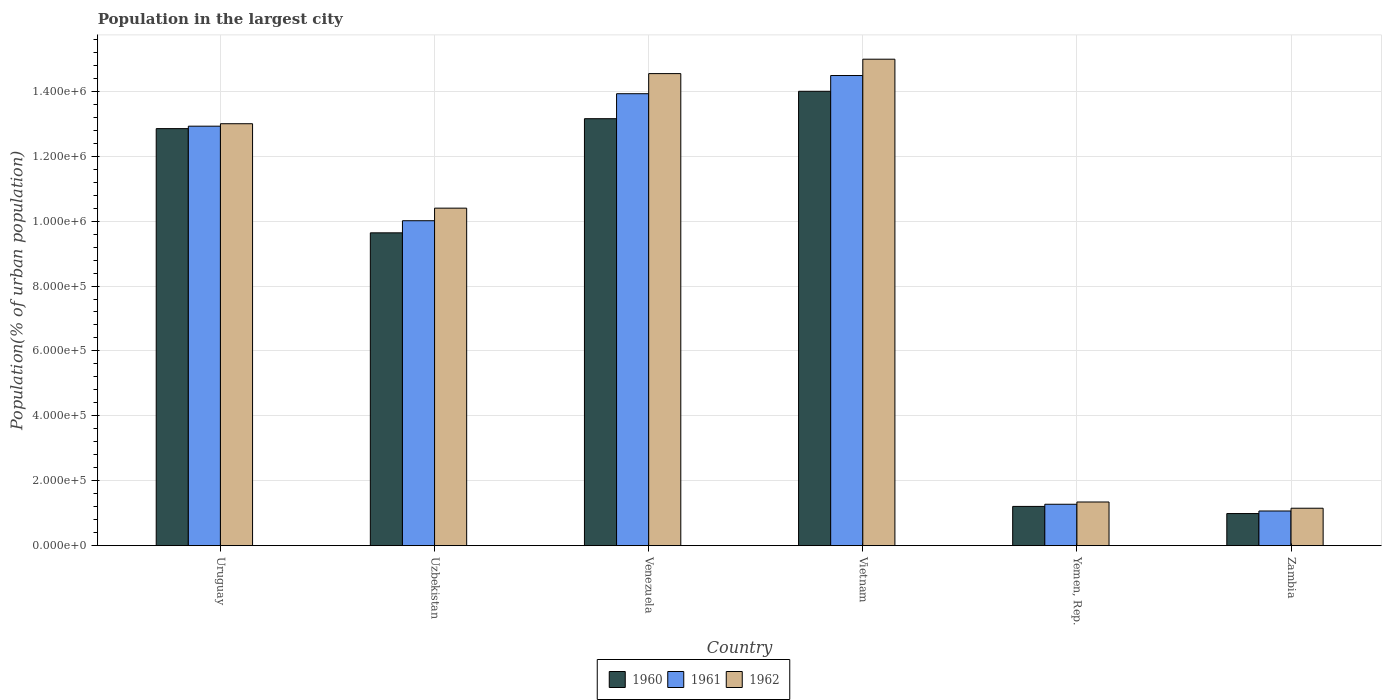How many different coloured bars are there?
Make the answer very short. 3. Are the number of bars per tick equal to the number of legend labels?
Ensure brevity in your answer.  Yes. Are the number of bars on each tick of the X-axis equal?
Provide a succinct answer. Yes. What is the label of the 3rd group of bars from the left?
Give a very brief answer. Venezuela. In how many cases, is the number of bars for a given country not equal to the number of legend labels?
Your answer should be very brief. 0. What is the population in the largest city in 1960 in Yemen, Rep.?
Offer a terse response. 1.21e+05. Across all countries, what is the maximum population in the largest city in 1962?
Ensure brevity in your answer.  1.50e+06. Across all countries, what is the minimum population in the largest city in 1961?
Offer a very short reply. 1.07e+05. In which country was the population in the largest city in 1961 maximum?
Make the answer very short. Vietnam. In which country was the population in the largest city in 1960 minimum?
Your answer should be compact. Zambia. What is the total population in the largest city in 1962 in the graph?
Offer a very short reply. 5.54e+06. What is the difference between the population in the largest city in 1960 in Uzbekistan and that in Yemen, Rep.?
Your answer should be very brief. 8.43e+05. What is the difference between the population in the largest city in 1962 in Uzbekistan and the population in the largest city in 1960 in Venezuela?
Your response must be concise. -2.76e+05. What is the average population in the largest city in 1962 per country?
Keep it short and to the point. 9.24e+05. What is the difference between the population in the largest city of/in 1960 and population in the largest city of/in 1961 in Yemen, Rep.?
Ensure brevity in your answer.  -6622. What is the ratio of the population in the largest city in 1960 in Venezuela to that in Vietnam?
Keep it short and to the point. 0.94. Is the population in the largest city in 1961 in Uruguay less than that in Yemen, Rep.?
Make the answer very short. No. Is the difference between the population in the largest city in 1960 in Venezuela and Zambia greater than the difference between the population in the largest city in 1961 in Venezuela and Zambia?
Provide a short and direct response. No. What is the difference between the highest and the second highest population in the largest city in 1961?
Provide a succinct answer. 1.00e+05. What is the difference between the highest and the lowest population in the largest city in 1960?
Your response must be concise. 1.30e+06. Is it the case that in every country, the sum of the population in the largest city in 1960 and population in the largest city in 1961 is greater than the population in the largest city in 1962?
Your answer should be compact. Yes. How many bars are there?
Keep it short and to the point. 18. How many countries are there in the graph?
Provide a short and direct response. 6. Are the values on the major ticks of Y-axis written in scientific E-notation?
Keep it short and to the point. Yes. Where does the legend appear in the graph?
Ensure brevity in your answer.  Bottom center. How many legend labels are there?
Ensure brevity in your answer.  3. How are the legend labels stacked?
Ensure brevity in your answer.  Horizontal. What is the title of the graph?
Give a very brief answer. Population in the largest city. Does "2011" appear as one of the legend labels in the graph?
Your answer should be very brief. No. What is the label or title of the X-axis?
Your response must be concise. Country. What is the label or title of the Y-axis?
Your response must be concise. Population(% of urban population). What is the Population(% of urban population) in 1960 in Uruguay?
Provide a succinct answer. 1.28e+06. What is the Population(% of urban population) in 1961 in Uruguay?
Your answer should be very brief. 1.29e+06. What is the Population(% of urban population) of 1962 in Uruguay?
Your response must be concise. 1.30e+06. What is the Population(% of urban population) of 1960 in Uzbekistan?
Provide a succinct answer. 9.64e+05. What is the Population(% of urban population) in 1961 in Uzbekistan?
Keep it short and to the point. 1.00e+06. What is the Population(% of urban population) in 1962 in Uzbekistan?
Provide a short and direct response. 1.04e+06. What is the Population(% of urban population) in 1960 in Venezuela?
Provide a succinct answer. 1.32e+06. What is the Population(% of urban population) in 1961 in Venezuela?
Ensure brevity in your answer.  1.39e+06. What is the Population(% of urban population) of 1962 in Venezuela?
Your answer should be very brief. 1.45e+06. What is the Population(% of urban population) of 1960 in Vietnam?
Ensure brevity in your answer.  1.40e+06. What is the Population(% of urban population) of 1961 in Vietnam?
Make the answer very short. 1.45e+06. What is the Population(% of urban population) of 1962 in Vietnam?
Your response must be concise. 1.50e+06. What is the Population(% of urban population) in 1960 in Yemen, Rep.?
Keep it short and to the point. 1.21e+05. What is the Population(% of urban population) in 1961 in Yemen, Rep.?
Give a very brief answer. 1.28e+05. What is the Population(% of urban population) of 1962 in Yemen, Rep.?
Provide a succinct answer. 1.35e+05. What is the Population(% of urban population) of 1960 in Zambia?
Your response must be concise. 9.90e+04. What is the Population(% of urban population) of 1961 in Zambia?
Ensure brevity in your answer.  1.07e+05. What is the Population(% of urban population) in 1962 in Zambia?
Offer a terse response. 1.15e+05. Across all countries, what is the maximum Population(% of urban population) of 1960?
Keep it short and to the point. 1.40e+06. Across all countries, what is the maximum Population(% of urban population) in 1961?
Offer a terse response. 1.45e+06. Across all countries, what is the maximum Population(% of urban population) in 1962?
Provide a succinct answer. 1.50e+06. Across all countries, what is the minimum Population(% of urban population) in 1960?
Provide a short and direct response. 9.90e+04. Across all countries, what is the minimum Population(% of urban population) of 1961?
Your answer should be very brief. 1.07e+05. Across all countries, what is the minimum Population(% of urban population) in 1962?
Your answer should be compact. 1.15e+05. What is the total Population(% of urban population) of 1960 in the graph?
Ensure brevity in your answer.  5.18e+06. What is the total Population(% of urban population) of 1961 in the graph?
Make the answer very short. 5.37e+06. What is the total Population(% of urban population) of 1962 in the graph?
Your answer should be very brief. 5.54e+06. What is the difference between the Population(% of urban population) of 1960 in Uruguay and that in Uzbekistan?
Give a very brief answer. 3.21e+05. What is the difference between the Population(% of urban population) in 1961 in Uruguay and that in Uzbekistan?
Your response must be concise. 2.91e+05. What is the difference between the Population(% of urban population) in 1962 in Uruguay and that in Uzbekistan?
Ensure brevity in your answer.  2.60e+05. What is the difference between the Population(% of urban population) in 1960 in Uruguay and that in Venezuela?
Your response must be concise. -3.06e+04. What is the difference between the Population(% of urban population) of 1961 in Uruguay and that in Venezuela?
Make the answer very short. -1.00e+05. What is the difference between the Population(% of urban population) of 1962 in Uruguay and that in Venezuela?
Ensure brevity in your answer.  -1.54e+05. What is the difference between the Population(% of urban population) in 1960 in Uruguay and that in Vietnam?
Give a very brief answer. -1.15e+05. What is the difference between the Population(% of urban population) of 1961 in Uruguay and that in Vietnam?
Provide a succinct answer. -1.56e+05. What is the difference between the Population(% of urban population) of 1962 in Uruguay and that in Vietnam?
Your response must be concise. -1.99e+05. What is the difference between the Population(% of urban population) of 1960 in Uruguay and that in Yemen, Rep.?
Your response must be concise. 1.16e+06. What is the difference between the Population(% of urban population) in 1961 in Uruguay and that in Yemen, Rep.?
Provide a short and direct response. 1.16e+06. What is the difference between the Population(% of urban population) in 1962 in Uruguay and that in Yemen, Rep.?
Give a very brief answer. 1.17e+06. What is the difference between the Population(% of urban population) of 1960 in Uruguay and that in Zambia?
Provide a succinct answer. 1.19e+06. What is the difference between the Population(% of urban population) in 1961 in Uruguay and that in Zambia?
Your response must be concise. 1.19e+06. What is the difference between the Population(% of urban population) of 1962 in Uruguay and that in Zambia?
Provide a short and direct response. 1.18e+06. What is the difference between the Population(% of urban population) in 1960 in Uzbekistan and that in Venezuela?
Your response must be concise. -3.52e+05. What is the difference between the Population(% of urban population) of 1961 in Uzbekistan and that in Venezuela?
Your answer should be compact. -3.91e+05. What is the difference between the Population(% of urban population) of 1962 in Uzbekistan and that in Venezuela?
Provide a short and direct response. -4.15e+05. What is the difference between the Population(% of urban population) in 1960 in Uzbekistan and that in Vietnam?
Your answer should be compact. -4.36e+05. What is the difference between the Population(% of urban population) of 1961 in Uzbekistan and that in Vietnam?
Offer a terse response. -4.47e+05. What is the difference between the Population(% of urban population) of 1962 in Uzbekistan and that in Vietnam?
Your response must be concise. -4.59e+05. What is the difference between the Population(% of urban population) in 1960 in Uzbekistan and that in Yemen, Rep.?
Keep it short and to the point. 8.43e+05. What is the difference between the Population(% of urban population) of 1961 in Uzbekistan and that in Yemen, Rep.?
Keep it short and to the point. 8.74e+05. What is the difference between the Population(% of urban population) of 1962 in Uzbekistan and that in Yemen, Rep.?
Your response must be concise. 9.05e+05. What is the difference between the Population(% of urban population) in 1960 in Uzbekistan and that in Zambia?
Offer a terse response. 8.65e+05. What is the difference between the Population(% of urban population) in 1961 in Uzbekistan and that in Zambia?
Ensure brevity in your answer.  8.94e+05. What is the difference between the Population(% of urban population) in 1962 in Uzbekistan and that in Zambia?
Keep it short and to the point. 9.25e+05. What is the difference between the Population(% of urban population) in 1960 in Venezuela and that in Vietnam?
Make the answer very short. -8.45e+04. What is the difference between the Population(% of urban population) of 1961 in Venezuela and that in Vietnam?
Keep it short and to the point. -5.60e+04. What is the difference between the Population(% of urban population) of 1962 in Venezuela and that in Vietnam?
Ensure brevity in your answer.  -4.44e+04. What is the difference between the Population(% of urban population) of 1960 in Venezuela and that in Yemen, Rep.?
Offer a terse response. 1.19e+06. What is the difference between the Population(% of urban population) of 1961 in Venezuela and that in Yemen, Rep.?
Offer a very short reply. 1.26e+06. What is the difference between the Population(% of urban population) in 1962 in Venezuela and that in Yemen, Rep.?
Offer a terse response. 1.32e+06. What is the difference between the Population(% of urban population) of 1960 in Venezuela and that in Zambia?
Provide a short and direct response. 1.22e+06. What is the difference between the Population(% of urban population) of 1961 in Venezuela and that in Zambia?
Your answer should be compact. 1.29e+06. What is the difference between the Population(% of urban population) in 1962 in Venezuela and that in Zambia?
Provide a succinct answer. 1.34e+06. What is the difference between the Population(% of urban population) of 1960 in Vietnam and that in Yemen, Rep.?
Your answer should be very brief. 1.28e+06. What is the difference between the Population(% of urban population) of 1961 in Vietnam and that in Yemen, Rep.?
Offer a terse response. 1.32e+06. What is the difference between the Population(% of urban population) in 1962 in Vietnam and that in Yemen, Rep.?
Keep it short and to the point. 1.36e+06. What is the difference between the Population(% of urban population) of 1960 in Vietnam and that in Zambia?
Your response must be concise. 1.30e+06. What is the difference between the Population(% of urban population) in 1961 in Vietnam and that in Zambia?
Make the answer very short. 1.34e+06. What is the difference between the Population(% of urban population) of 1962 in Vietnam and that in Zambia?
Keep it short and to the point. 1.38e+06. What is the difference between the Population(% of urban population) of 1960 in Yemen, Rep. and that in Zambia?
Make the answer very short. 2.20e+04. What is the difference between the Population(% of urban population) of 1961 in Yemen, Rep. and that in Zambia?
Make the answer very short. 2.08e+04. What is the difference between the Population(% of urban population) of 1962 in Yemen, Rep. and that in Zambia?
Your response must be concise. 1.92e+04. What is the difference between the Population(% of urban population) of 1960 in Uruguay and the Population(% of urban population) of 1961 in Uzbekistan?
Provide a succinct answer. 2.84e+05. What is the difference between the Population(% of urban population) in 1960 in Uruguay and the Population(% of urban population) in 1962 in Uzbekistan?
Ensure brevity in your answer.  2.45e+05. What is the difference between the Population(% of urban population) in 1961 in Uruguay and the Population(% of urban population) in 1962 in Uzbekistan?
Your response must be concise. 2.53e+05. What is the difference between the Population(% of urban population) of 1960 in Uruguay and the Population(% of urban population) of 1961 in Venezuela?
Offer a terse response. -1.08e+05. What is the difference between the Population(% of urban population) of 1960 in Uruguay and the Population(% of urban population) of 1962 in Venezuela?
Your answer should be very brief. -1.70e+05. What is the difference between the Population(% of urban population) of 1961 in Uruguay and the Population(% of urban population) of 1962 in Venezuela?
Ensure brevity in your answer.  -1.62e+05. What is the difference between the Population(% of urban population) in 1960 in Uruguay and the Population(% of urban population) in 1961 in Vietnam?
Make the answer very short. -1.64e+05. What is the difference between the Population(% of urban population) of 1960 in Uruguay and the Population(% of urban population) of 1962 in Vietnam?
Offer a very short reply. -2.14e+05. What is the difference between the Population(% of urban population) in 1961 in Uruguay and the Population(% of urban population) in 1962 in Vietnam?
Your response must be concise. -2.06e+05. What is the difference between the Population(% of urban population) of 1960 in Uruguay and the Population(% of urban population) of 1961 in Yemen, Rep.?
Make the answer very short. 1.16e+06. What is the difference between the Population(% of urban population) in 1960 in Uruguay and the Population(% of urban population) in 1962 in Yemen, Rep.?
Offer a terse response. 1.15e+06. What is the difference between the Population(% of urban population) of 1961 in Uruguay and the Population(% of urban population) of 1962 in Yemen, Rep.?
Offer a terse response. 1.16e+06. What is the difference between the Population(% of urban population) of 1960 in Uruguay and the Population(% of urban population) of 1961 in Zambia?
Offer a terse response. 1.18e+06. What is the difference between the Population(% of urban population) in 1960 in Uruguay and the Population(% of urban population) in 1962 in Zambia?
Offer a very short reply. 1.17e+06. What is the difference between the Population(% of urban population) in 1961 in Uruguay and the Population(% of urban population) in 1962 in Zambia?
Provide a succinct answer. 1.18e+06. What is the difference between the Population(% of urban population) of 1960 in Uzbekistan and the Population(% of urban population) of 1961 in Venezuela?
Keep it short and to the point. -4.29e+05. What is the difference between the Population(% of urban population) of 1960 in Uzbekistan and the Population(% of urban population) of 1962 in Venezuela?
Your answer should be compact. -4.91e+05. What is the difference between the Population(% of urban population) of 1961 in Uzbekistan and the Population(% of urban population) of 1962 in Venezuela?
Provide a succinct answer. -4.53e+05. What is the difference between the Population(% of urban population) of 1960 in Uzbekistan and the Population(% of urban population) of 1961 in Vietnam?
Your answer should be very brief. -4.85e+05. What is the difference between the Population(% of urban population) of 1960 in Uzbekistan and the Population(% of urban population) of 1962 in Vietnam?
Offer a very short reply. -5.35e+05. What is the difference between the Population(% of urban population) in 1961 in Uzbekistan and the Population(% of urban population) in 1962 in Vietnam?
Ensure brevity in your answer.  -4.98e+05. What is the difference between the Population(% of urban population) in 1960 in Uzbekistan and the Population(% of urban population) in 1961 in Yemen, Rep.?
Ensure brevity in your answer.  8.36e+05. What is the difference between the Population(% of urban population) of 1960 in Uzbekistan and the Population(% of urban population) of 1962 in Yemen, Rep.?
Provide a short and direct response. 8.29e+05. What is the difference between the Population(% of urban population) of 1961 in Uzbekistan and the Population(% of urban population) of 1962 in Yemen, Rep.?
Offer a very short reply. 8.67e+05. What is the difference between the Population(% of urban population) in 1960 in Uzbekistan and the Population(% of urban population) in 1961 in Zambia?
Offer a terse response. 8.57e+05. What is the difference between the Population(% of urban population) of 1960 in Uzbekistan and the Population(% of urban population) of 1962 in Zambia?
Give a very brief answer. 8.49e+05. What is the difference between the Population(% of urban population) in 1961 in Uzbekistan and the Population(% of urban population) in 1962 in Zambia?
Provide a succinct answer. 8.86e+05. What is the difference between the Population(% of urban population) in 1960 in Venezuela and the Population(% of urban population) in 1961 in Vietnam?
Offer a terse response. -1.33e+05. What is the difference between the Population(% of urban population) in 1960 in Venezuela and the Population(% of urban population) in 1962 in Vietnam?
Keep it short and to the point. -1.83e+05. What is the difference between the Population(% of urban population) of 1961 in Venezuela and the Population(% of urban population) of 1962 in Vietnam?
Give a very brief answer. -1.06e+05. What is the difference between the Population(% of urban population) in 1960 in Venezuela and the Population(% of urban population) in 1961 in Yemen, Rep.?
Your answer should be compact. 1.19e+06. What is the difference between the Population(% of urban population) of 1960 in Venezuela and the Population(% of urban population) of 1962 in Yemen, Rep.?
Offer a terse response. 1.18e+06. What is the difference between the Population(% of urban population) in 1961 in Venezuela and the Population(% of urban population) in 1962 in Yemen, Rep.?
Your answer should be very brief. 1.26e+06. What is the difference between the Population(% of urban population) of 1960 in Venezuela and the Population(% of urban population) of 1961 in Zambia?
Make the answer very short. 1.21e+06. What is the difference between the Population(% of urban population) in 1960 in Venezuela and the Population(% of urban population) in 1962 in Zambia?
Make the answer very short. 1.20e+06. What is the difference between the Population(% of urban population) of 1961 in Venezuela and the Population(% of urban population) of 1962 in Zambia?
Your response must be concise. 1.28e+06. What is the difference between the Population(% of urban population) of 1960 in Vietnam and the Population(% of urban population) of 1961 in Yemen, Rep.?
Give a very brief answer. 1.27e+06. What is the difference between the Population(% of urban population) in 1960 in Vietnam and the Population(% of urban population) in 1962 in Yemen, Rep.?
Provide a short and direct response. 1.27e+06. What is the difference between the Population(% of urban population) of 1961 in Vietnam and the Population(% of urban population) of 1962 in Yemen, Rep.?
Provide a succinct answer. 1.31e+06. What is the difference between the Population(% of urban population) in 1960 in Vietnam and the Population(% of urban population) in 1961 in Zambia?
Ensure brevity in your answer.  1.29e+06. What is the difference between the Population(% of urban population) in 1960 in Vietnam and the Population(% of urban population) in 1962 in Zambia?
Offer a very short reply. 1.28e+06. What is the difference between the Population(% of urban population) in 1961 in Vietnam and the Population(% of urban population) in 1962 in Zambia?
Offer a very short reply. 1.33e+06. What is the difference between the Population(% of urban population) of 1960 in Yemen, Rep. and the Population(% of urban population) of 1961 in Zambia?
Offer a terse response. 1.41e+04. What is the difference between the Population(% of urban population) in 1960 in Yemen, Rep. and the Population(% of urban population) in 1962 in Zambia?
Provide a short and direct response. 5601. What is the difference between the Population(% of urban population) in 1961 in Yemen, Rep. and the Population(% of urban population) in 1962 in Zambia?
Provide a short and direct response. 1.22e+04. What is the average Population(% of urban population) in 1960 per country?
Your answer should be compact. 8.64e+05. What is the average Population(% of urban population) of 1961 per country?
Offer a terse response. 8.95e+05. What is the average Population(% of urban population) in 1962 per country?
Offer a very short reply. 9.24e+05. What is the difference between the Population(% of urban population) in 1960 and Population(% of urban population) in 1961 in Uruguay?
Ensure brevity in your answer.  -7522. What is the difference between the Population(% of urban population) in 1960 and Population(% of urban population) in 1962 in Uruguay?
Your answer should be very brief. -1.51e+04. What is the difference between the Population(% of urban population) in 1961 and Population(% of urban population) in 1962 in Uruguay?
Your response must be concise. -7578. What is the difference between the Population(% of urban population) in 1960 and Population(% of urban population) in 1961 in Uzbekistan?
Your answer should be very brief. -3.73e+04. What is the difference between the Population(% of urban population) of 1960 and Population(% of urban population) of 1962 in Uzbekistan?
Give a very brief answer. -7.60e+04. What is the difference between the Population(% of urban population) in 1961 and Population(% of urban population) in 1962 in Uzbekistan?
Ensure brevity in your answer.  -3.88e+04. What is the difference between the Population(% of urban population) in 1960 and Population(% of urban population) in 1961 in Venezuela?
Provide a short and direct response. -7.70e+04. What is the difference between the Population(% of urban population) of 1960 and Population(% of urban population) of 1962 in Venezuela?
Ensure brevity in your answer.  -1.39e+05. What is the difference between the Population(% of urban population) of 1961 and Population(% of urban population) of 1962 in Venezuela?
Offer a very short reply. -6.19e+04. What is the difference between the Population(% of urban population) in 1960 and Population(% of urban population) in 1961 in Vietnam?
Provide a short and direct response. -4.86e+04. What is the difference between the Population(% of urban population) of 1960 and Population(% of urban population) of 1962 in Vietnam?
Offer a very short reply. -9.89e+04. What is the difference between the Population(% of urban population) in 1961 and Population(% of urban population) in 1962 in Vietnam?
Provide a succinct answer. -5.03e+04. What is the difference between the Population(% of urban population) of 1960 and Population(% of urban population) of 1961 in Yemen, Rep.?
Provide a short and direct response. -6622. What is the difference between the Population(% of urban population) of 1960 and Population(% of urban population) of 1962 in Yemen, Rep.?
Offer a terse response. -1.36e+04. What is the difference between the Population(% of urban population) of 1961 and Population(% of urban population) of 1962 in Yemen, Rep.?
Your answer should be very brief. -6994. What is the difference between the Population(% of urban population) of 1960 and Population(% of urban population) of 1961 in Zambia?
Offer a very short reply. -7895. What is the difference between the Population(% of urban population) of 1960 and Population(% of urban population) of 1962 in Zambia?
Provide a succinct answer. -1.64e+04. What is the difference between the Population(% of urban population) of 1961 and Population(% of urban population) of 1962 in Zambia?
Ensure brevity in your answer.  -8536. What is the ratio of the Population(% of urban population) in 1960 in Uruguay to that in Uzbekistan?
Your response must be concise. 1.33. What is the ratio of the Population(% of urban population) of 1961 in Uruguay to that in Uzbekistan?
Offer a very short reply. 1.29. What is the ratio of the Population(% of urban population) of 1962 in Uruguay to that in Uzbekistan?
Give a very brief answer. 1.25. What is the ratio of the Population(% of urban population) of 1960 in Uruguay to that in Venezuela?
Offer a terse response. 0.98. What is the ratio of the Population(% of urban population) in 1961 in Uruguay to that in Venezuela?
Give a very brief answer. 0.93. What is the ratio of the Population(% of urban population) of 1962 in Uruguay to that in Venezuela?
Give a very brief answer. 0.89. What is the ratio of the Population(% of urban population) in 1960 in Uruguay to that in Vietnam?
Provide a short and direct response. 0.92. What is the ratio of the Population(% of urban population) in 1961 in Uruguay to that in Vietnam?
Provide a succinct answer. 0.89. What is the ratio of the Population(% of urban population) in 1962 in Uruguay to that in Vietnam?
Keep it short and to the point. 0.87. What is the ratio of the Population(% of urban population) in 1960 in Uruguay to that in Yemen, Rep.?
Offer a very short reply. 10.62. What is the ratio of the Population(% of urban population) of 1961 in Uruguay to that in Yemen, Rep.?
Provide a succinct answer. 10.13. What is the ratio of the Population(% of urban population) of 1962 in Uruguay to that in Yemen, Rep.?
Your answer should be very brief. 9.66. What is the ratio of the Population(% of urban population) in 1960 in Uruguay to that in Zambia?
Your answer should be compact. 12.98. What is the ratio of the Population(% of urban population) of 1961 in Uruguay to that in Zambia?
Give a very brief answer. 12.09. What is the ratio of the Population(% of urban population) of 1962 in Uruguay to that in Zambia?
Keep it short and to the point. 11.27. What is the ratio of the Population(% of urban population) of 1960 in Uzbekistan to that in Venezuela?
Your answer should be compact. 0.73. What is the ratio of the Population(% of urban population) of 1961 in Uzbekistan to that in Venezuela?
Offer a terse response. 0.72. What is the ratio of the Population(% of urban population) in 1962 in Uzbekistan to that in Venezuela?
Provide a succinct answer. 0.71. What is the ratio of the Population(% of urban population) in 1960 in Uzbekistan to that in Vietnam?
Make the answer very short. 0.69. What is the ratio of the Population(% of urban population) of 1961 in Uzbekistan to that in Vietnam?
Your answer should be very brief. 0.69. What is the ratio of the Population(% of urban population) of 1962 in Uzbekistan to that in Vietnam?
Offer a very short reply. 0.69. What is the ratio of the Population(% of urban population) of 1960 in Uzbekistan to that in Yemen, Rep.?
Offer a terse response. 7.97. What is the ratio of the Population(% of urban population) of 1961 in Uzbekistan to that in Yemen, Rep.?
Ensure brevity in your answer.  7.84. What is the ratio of the Population(% of urban population) in 1962 in Uzbekistan to that in Yemen, Rep.?
Ensure brevity in your answer.  7.73. What is the ratio of the Population(% of urban population) in 1960 in Uzbekistan to that in Zambia?
Make the answer very short. 9.74. What is the ratio of the Population(% of urban population) in 1961 in Uzbekistan to that in Zambia?
Your answer should be compact. 9.37. What is the ratio of the Population(% of urban population) of 1962 in Uzbekistan to that in Zambia?
Ensure brevity in your answer.  9.01. What is the ratio of the Population(% of urban population) in 1960 in Venezuela to that in Vietnam?
Offer a very short reply. 0.94. What is the ratio of the Population(% of urban population) in 1961 in Venezuela to that in Vietnam?
Make the answer very short. 0.96. What is the ratio of the Population(% of urban population) in 1962 in Venezuela to that in Vietnam?
Offer a terse response. 0.97. What is the ratio of the Population(% of urban population) of 1960 in Venezuela to that in Yemen, Rep.?
Give a very brief answer. 10.87. What is the ratio of the Population(% of urban population) of 1961 in Venezuela to that in Yemen, Rep.?
Keep it short and to the point. 10.91. What is the ratio of the Population(% of urban population) of 1962 in Venezuela to that in Yemen, Rep.?
Your answer should be compact. 10.8. What is the ratio of the Population(% of urban population) of 1960 in Venezuela to that in Zambia?
Your response must be concise. 13.29. What is the ratio of the Population(% of urban population) in 1961 in Venezuela to that in Zambia?
Keep it short and to the point. 13.03. What is the ratio of the Population(% of urban population) in 1962 in Venezuela to that in Zambia?
Your answer should be very brief. 12.6. What is the ratio of the Population(% of urban population) of 1960 in Vietnam to that in Yemen, Rep.?
Offer a very short reply. 11.57. What is the ratio of the Population(% of urban population) of 1961 in Vietnam to that in Yemen, Rep.?
Your answer should be compact. 11.35. What is the ratio of the Population(% of urban population) in 1962 in Vietnam to that in Yemen, Rep.?
Provide a succinct answer. 11.13. What is the ratio of the Population(% of urban population) of 1960 in Vietnam to that in Zambia?
Offer a very short reply. 14.15. What is the ratio of the Population(% of urban population) in 1961 in Vietnam to that in Zambia?
Your answer should be compact. 13.56. What is the ratio of the Population(% of urban population) in 1962 in Vietnam to that in Zambia?
Make the answer very short. 12.99. What is the ratio of the Population(% of urban population) in 1960 in Yemen, Rep. to that in Zambia?
Ensure brevity in your answer.  1.22. What is the ratio of the Population(% of urban population) of 1961 in Yemen, Rep. to that in Zambia?
Ensure brevity in your answer.  1.19. What is the ratio of the Population(% of urban population) of 1962 in Yemen, Rep. to that in Zambia?
Make the answer very short. 1.17. What is the difference between the highest and the second highest Population(% of urban population) of 1960?
Make the answer very short. 8.45e+04. What is the difference between the highest and the second highest Population(% of urban population) of 1961?
Provide a short and direct response. 5.60e+04. What is the difference between the highest and the second highest Population(% of urban population) in 1962?
Your response must be concise. 4.44e+04. What is the difference between the highest and the lowest Population(% of urban population) of 1960?
Offer a terse response. 1.30e+06. What is the difference between the highest and the lowest Population(% of urban population) in 1961?
Keep it short and to the point. 1.34e+06. What is the difference between the highest and the lowest Population(% of urban population) in 1962?
Make the answer very short. 1.38e+06. 